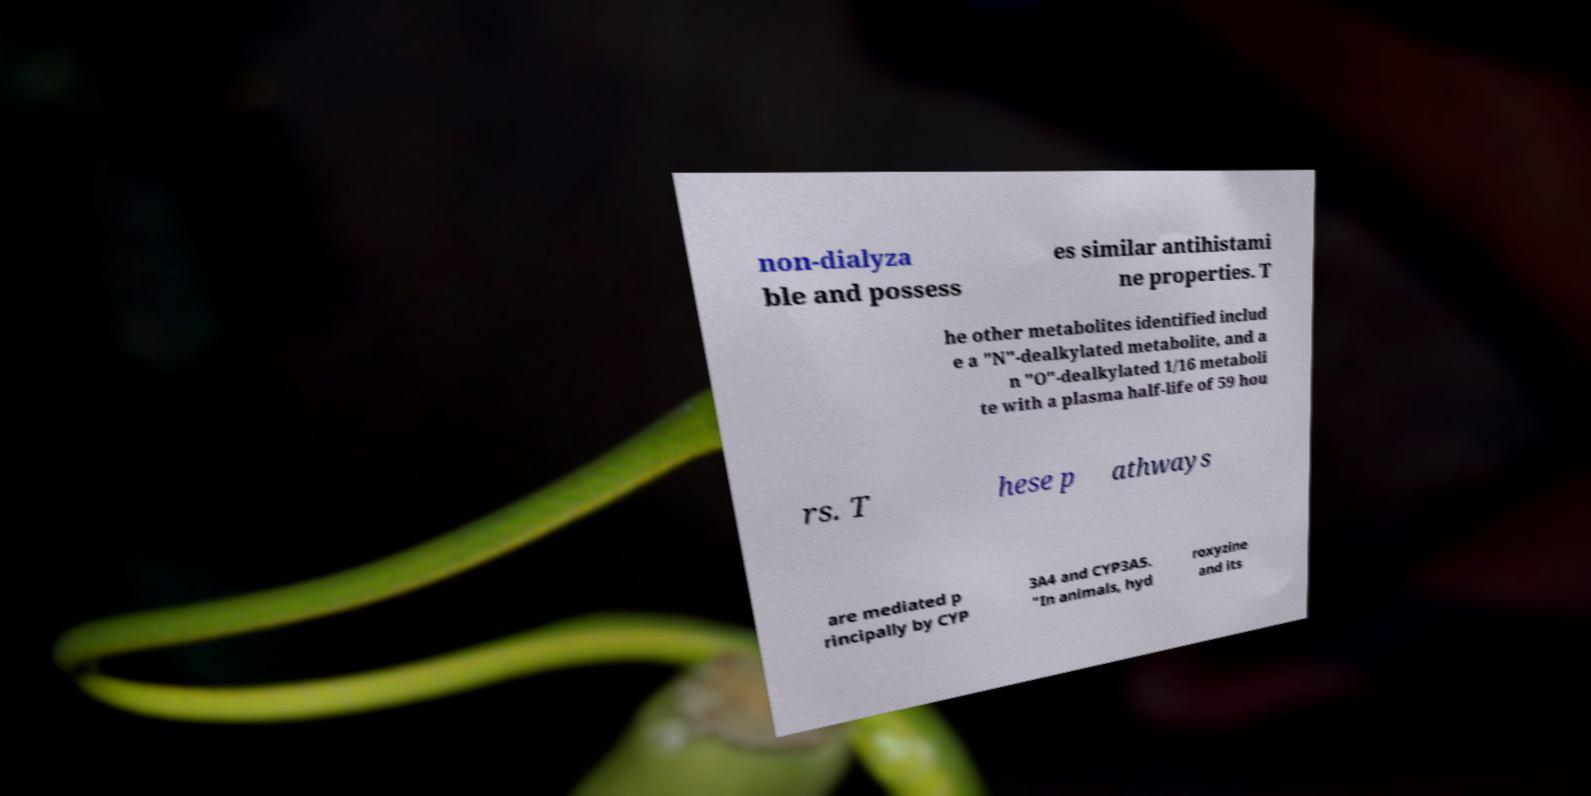Please read and relay the text visible in this image. What does it say? non-dialyza ble and possess es similar antihistami ne properties. T he other metabolites identified includ e a "N"-dealkylated metabolite, and a n "O"-dealkylated 1/16 metaboli te with a plasma half-life of 59 hou rs. T hese p athways are mediated p rincipally by CYP 3A4 and CYP3A5. "In animals, hyd roxyzine and its 